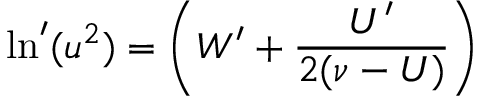<formula> <loc_0><loc_0><loc_500><loc_500>\ln ^ { \prime } ( u ^ { 2 } ) = \left ( W ^ { \prime } + \frac { U ^ { \prime } } { 2 ( \nu - U ) } \right )</formula> 